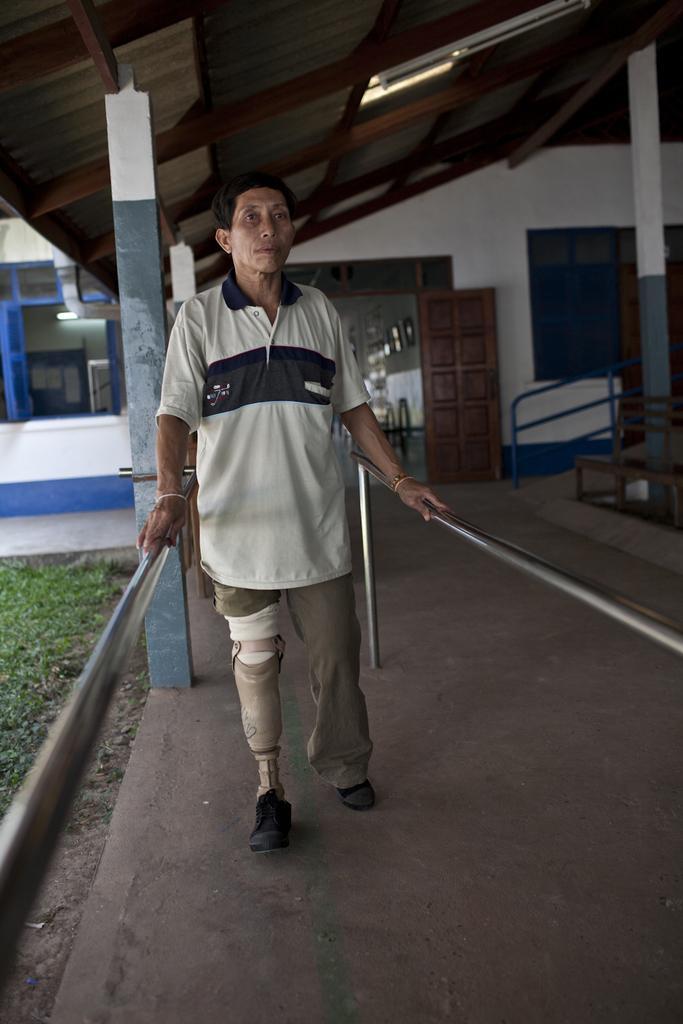How would you summarize this image in a sentence or two? In this image we can see a person standing on the floor and holding grills on either sides. In the background there are shed, ramp, doors, walls, windows and grass. 